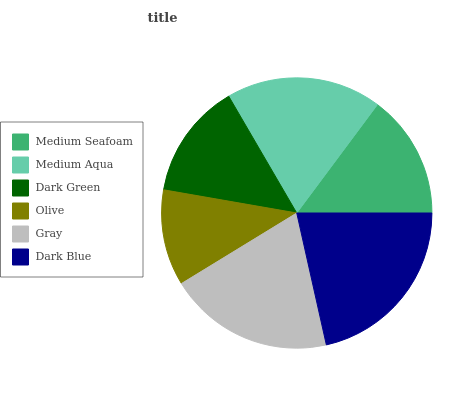Is Olive the minimum?
Answer yes or no. Yes. Is Dark Blue the maximum?
Answer yes or no. Yes. Is Medium Aqua the minimum?
Answer yes or no. No. Is Medium Aqua the maximum?
Answer yes or no. No. Is Medium Aqua greater than Medium Seafoam?
Answer yes or no. Yes. Is Medium Seafoam less than Medium Aqua?
Answer yes or no. Yes. Is Medium Seafoam greater than Medium Aqua?
Answer yes or no. No. Is Medium Aqua less than Medium Seafoam?
Answer yes or no. No. Is Medium Aqua the high median?
Answer yes or no. Yes. Is Medium Seafoam the low median?
Answer yes or no. Yes. Is Gray the high median?
Answer yes or no. No. Is Olive the low median?
Answer yes or no. No. 